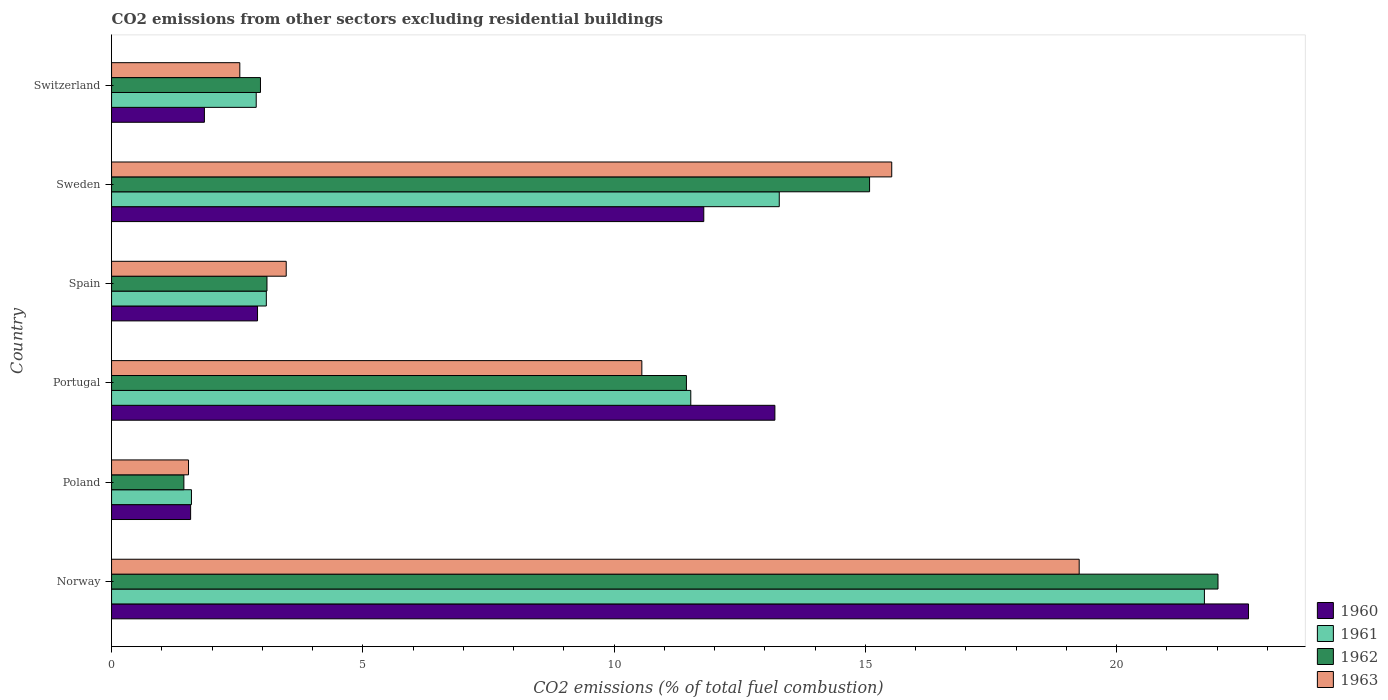How many different coloured bars are there?
Make the answer very short. 4. How many groups of bars are there?
Your response must be concise. 6. Are the number of bars per tick equal to the number of legend labels?
Provide a succinct answer. Yes. Are the number of bars on each tick of the Y-axis equal?
Make the answer very short. Yes. How many bars are there on the 4th tick from the top?
Your answer should be very brief. 4. How many bars are there on the 4th tick from the bottom?
Your answer should be compact. 4. What is the label of the 1st group of bars from the top?
Your answer should be very brief. Switzerland. What is the total CO2 emitted in 1963 in Switzerland?
Your answer should be very brief. 2.55. Across all countries, what is the maximum total CO2 emitted in 1962?
Offer a very short reply. 22.02. Across all countries, what is the minimum total CO2 emitted in 1960?
Your answer should be very brief. 1.57. In which country was the total CO2 emitted in 1960 minimum?
Ensure brevity in your answer.  Poland. What is the total total CO2 emitted in 1961 in the graph?
Your answer should be compact. 54.11. What is the difference between the total CO2 emitted in 1961 in Norway and that in Sweden?
Give a very brief answer. 8.46. What is the difference between the total CO2 emitted in 1962 in Sweden and the total CO2 emitted in 1960 in Spain?
Ensure brevity in your answer.  12.18. What is the average total CO2 emitted in 1961 per country?
Ensure brevity in your answer.  9.02. What is the difference between the total CO2 emitted in 1960 and total CO2 emitted in 1963 in Switzerland?
Make the answer very short. -0.7. What is the ratio of the total CO2 emitted in 1961 in Poland to that in Spain?
Ensure brevity in your answer.  0.52. Is the total CO2 emitted in 1962 in Norway less than that in Portugal?
Ensure brevity in your answer.  No. Is the difference between the total CO2 emitted in 1960 in Poland and Portugal greater than the difference between the total CO2 emitted in 1963 in Poland and Portugal?
Ensure brevity in your answer.  No. What is the difference between the highest and the second highest total CO2 emitted in 1960?
Provide a succinct answer. 9.43. What is the difference between the highest and the lowest total CO2 emitted in 1961?
Keep it short and to the point. 20.16. In how many countries, is the total CO2 emitted in 1962 greater than the average total CO2 emitted in 1962 taken over all countries?
Give a very brief answer. 3. What does the 2nd bar from the top in Switzerland represents?
Keep it short and to the point. 1962. What does the 3rd bar from the bottom in Portugal represents?
Your answer should be compact. 1962. Are all the bars in the graph horizontal?
Your response must be concise. Yes. Are the values on the major ticks of X-axis written in scientific E-notation?
Keep it short and to the point. No. Does the graph contain any zero values?
Provide a short and direct response. No. Does the graph contain grids?
Offer a very short reply. No. What is the title of the graph?
Provide a short and direct response. CO2 emissions from other sectors excluding residential buildings. Does "1995" appear as one of the legend labels in the graph?
Your response must be concise. No. What is the label or title of the X-axis?
Make the answer very short. CO2 emissions (% of total fuel combustion). What is the CO2 emissions (% of total fuel combustion) of 1960 in Norway?
Your answer should be compact. 22.63. What is the CO2 emissions (% of total fuel combustion) of 1961 in Norway?
Your answer should be very brief. 21.75. What is the CO2 emissions (% of total fuel combustion) of 1962 in Norway?
Offer a very short reply. 22.02. What is the CO2 emissions (% of total fuel combustion) of 1963 in Norway?
Your answer should be compact. 19.26. What is the CO2 emissions (% of total fuel combustion) of 1960 in Poland?
Give a very brief answer. 1.57. What is the CO2 emissions (% of total fuel combustion) in 1961 in Poland?
Provide a succinct answer. 1.59. What is the CO2 emissions (% of total fuel combustion) of 1962 in Poland?
Keep it short and to the point. 1.44. What is the CO2 emissions (% of total fuel combustion) in 1963 in Poland?
Offer a terse response. 1.53. What is the CO2 emissions (% of total fuel combustion) of 1960 in Portugal?
Ensure brevity in your answer.  13.2. What is the CO2 emissions (% of total fuel combustion) in 1961 in Portugal?
Give a very brief answer. 11.53. What is the CO2 emissions (% of total fuel combustion) in 1962 in Portugal?
Give a very brief answer. 11.44. What is the CO2 emissions (% of total fuel combustion) in 1963 in Portugal?
Give a very brief answer. 10.55. What is the CO2 emissions (% of total fuel combustion) in 1960 in Spain?
Your response must be concise. 2.91. What is the CO2 emissions (% of total fuel combustion) of 1961 in Spain?
Ensure brevity in your answer.  3.08. What is the CO2 emissions (% of total fuel combustion) of 1962 in Spain?
Your answer should be very brief. 3.09. What is the CO2 emissions (% of total fuel combustion) of 1963 in Spain?
Give a very brief answer. 3.48. What is the CO2 emissions (% of total fuel combustion) of 1960 in Sweden?
Provide a succinct answer. 11.79. What is the CO2 emissions (% of total fuel combustion) of 1961 in Sweden?
Keep it short and to the point. 13.29. What is the CO2 emissions (% of total fuel combustion) in 1962 in Sweden?
Offer a terse response. 15.09. What is the CO2 emissions (% of total fuel combustion) in 1963 in Sweden?
Offer a terse response. 15.53. What is the CO2 emissions (% of total fuel combustion) of 1960 in Switzerland?
Offer a very short reply. 1.85. What is the CO2 emissions (% of total fuel combustion) of 1961 in Switzerland?
Your answer should be very brief. 2.88. What is the CO2 emissions (% of total fuel combustion) in 1962 in Switzerland?
Ensure brevity in your answer.  2.96. What is the CO2 emissions (% of total fuel combustion) of 1963 in Switzerland?
Your answer should be very brief. 2.55. Across all countries, what is the maximum CO2 emissions (% of total fuel combustion) of 1960?
Provide a short and direct response. 22.63. Across all countries, what is the maximum CO2 emissions (% of total fuel combustion) in 1961?
Provide a short and direct response. 21.75. Across all countries, what is the maximum CO2 emissions (% of total fuel combustion) of 1962?
Offer a very short reply. 22.02. Across all countries, what is the maximum CO2 emissions (% of total fuel combustion) in 1963?
Ensure brevity in your answer.  19.26. Across all countries, what is the minimum CO2 emissions (% of total fuel combustion) in 1960?
Offer a terse response. 1.57. Across all countries, what is the minimum CO2 emissions (% of total fuel combustion) in 1961?
Offer a very short reply. 1.59. Across all countries, what is the minimum CO2 emissions (% of total fuel combustion) of 1962?
Make the answer very short. 1.44. Across all countries, what is the minimum CO2 emissions (% of total fuel combustion) in 1963?
Ensure brevity in your answer.  1.53. What is the total CO2 emissions (% of total fuel combustion) in 1960 in the graph?
Make the answer very short. 53.94. What is the total CO2 emissions (% of total fuel combustion) in 1961 in the graph?
Your response must be concise. 54.11. What is the total CO2 emissions (% of total fuel combustion) in 1962 in the graph?
Offer a very short reply. 56.04. What is the total CO2 emissions (% of total fuel combustion) of 1963 in the graph?
Give a very brief answer. 52.9. What is the difference between the CO2 emissions (% of total fuel combustion) of 1960 in Norway and that in Poland?
Your answer should be very brief. 21.05. What is the difference between the CO2 emissions (% of total fuel combustion) in 1961 in Norway and that in Poland?
Ensure brevity in your answer.  20.16. What is the difference between the CO2 emissions (% of total fuel combustion) of 1962 in Norway and that in Poland?
Ensure brevity in your answer.  20.58. What is the difference between the CO2 emissions (% of total fuel combustion) in 1963 in Norway and that in Poland?
Offer a terse response. 17.73. What is the difference between the CO2 emissions (% of total fuel combustion) in 1960 in Norway and that in Portugal?
Your answer should be compact. 9.43. What is the difference between the CO2 emissions (% of total fuel combustion) in 1961 in Norway and that in Portugal?
Your answer should be compact. 10.22. What is the difference between the CO2 emissions (% of total fuel combustion) of 1962 in Norway and that in Portugal?
Provide a succinct answer. 10.58. What is the difference between the CO2 emissions (% of total fuel combustion) in 1963 in Norway and that in Portugal?
Make the answer very short. 8.7. What is the difference between the CO2 emissions (% of total fuel combustion) of 1960 in Norway and that in Spain?
Ensure brevity in your answer.  19.72. What is the difference between the CO2 emissions (% of total fuel combustion) in 1961 in Norway and that in Spain?
Your answer should be compact. 18.67. What is the difference between the CO2 emissions (% of total fuel combustion) in 1962 in Norway and that in Spain?
Your answer should be very brief. 18.93. What is the difference between the CO2 emissions (% of total fuel combustion) in 1963 in Norway and that in Spain?
Provide a succinct answer. 15.78. What is the difference between the CO2 emissions (% of total fuel combustion) of 1960 in Norway and that in Sweden?
Your answer should be very brief. 10.84. What is the difference between the CO2 emissions (% of total fuel combustion) of 1961 in Norway and that in Sweden?
Give a very brief answer. 8.46. What is the difference between the CO2 emissions (% of total fuel combustion) of 1962 in Norway and that in Sweden?
Provide a succinct answer. 6.93. What is the difference between the CO2 emissions (% of total fuel combustion) in 1963 in Norway and that in Sweden?
Ensure brevity in your answer.  3.73. What is the difference between the CO2 emissions (% of total fuel combustion) in 1960 in Norway and that in Switzerland?
Provide a succinct answer. 20.78. What is the difference between the CO2 emissions (% of total fuel combustion) in 1961 in Norway and that in Switzerland?
Give a very brief answer. 18.87. What is the difference between the CO2 emissions (% of total fuel combustion) in 1962 in Norway and that in Switzerland?
Make the answer very short. 19.06. What is the difference between the CO2 emissions (% of total fuel combustion) of 1963 in Norway and that in Switzerland?
Ensure brevity in your answer.  16.7. What is the difference between the CO2 emissions (% of total fuel combustion) in 1960 in Poland and that in Portugal?
Offer a terse response. -11.63. What is the difference between the CO2 emissions (% of total fuel combustion) in 1961 in Poland and that in Portugal?
Ensure brevity in your answer.  -9.94. What is the difference between the CO2 emissions (% of total fuel combustion) in 1962 in Poland and that in Portugal?
Your answer should be very brief. -10. What is the difference between the CO2 emissions (% of total fuel combustion) of 1963 in Poland and that in Portugal?
Ensure brevity in your answer.  -9.02. What is the difference between the CO2 emissions (% of total fuel combustion) of 1960 in Poland and that in Spain?
Give a very brief answer. -1.33. What is the difference between the CO2 emissions (% of total fuel combustion) of 1961 in Poland and that in Spain?
Provide a succinct answer. -1.49. What is the difference between the CO2 emissions (% of total fuel combustion) of 1962 in Poland and that in Spain?
Make the answer very short. -1.65. What is the difference between the CO2 emissions (% of total fuel combustion) of 1963 in Poland and that in Spain?
Your answer should be very brief. -1.94. What is the difference between the CO2 emissions (% of total fuel combustion) in 1960 in Poland and that in Sweden?
Make the answer very short. -10.21. What is the difference between the CO2 emissions (% of total fuel combustion) in 1961 in Poland and that in Sweden?
Provide a short and direct response. -11.7. What is the difference between the CO2 emissions (% of total fuel combustion) in 1962 in Poland and that in Sweden?
Provide a succinct answer. -13.65. What is the difference between the CO2 emissions (% of total fuel combustion) in 1963 in Poland and that in Sweden?
Ensure brevity in your answer.  -13.99. What is the difference between the CO2 emissions (% of total fuel combustion) in 1960 in Poland and that in Switzerland?
Give a very brief answer. -0.27. What is the difference between the CO2 emissions (% of total fuel combustion) of 1961 in Poland and that in Switzerland?
Provide a succinct answer. -1.29. What is the difference between the CO2 emissions (% of total fuel combustion) of 1962 in Poland and that in Switzerland?
Give a very brief answer. -1.52. What is the difference between the CO2 emissions (% of total fuel combustion) of 1963 in Poland and that in Switzerland?
Your response must be concise. -1.02. What is the difference between the CO2 emissions (% of total fuel combustion) in 1960 in Portugal and that in Spain?
Provide a short and direct response. 10.3. What is the difference between the CO2 emissions (% of total fuel combustion) in 1961 in Portugal and that in Spain?
Provide a short and direct response. 8.45. What is the difference between the CO2 emissions (% of total fuel combustion) in 1962 in Portugal and that in Spain?
Your answer should be very brief. 8.35. What is the difference between the CO2 emissions (% of total fuel combustion) of 1963 in Portugal and that in Spain?
Make the answer very short. 7.08. What is the difference between the CO2 emissions (% of total fuel combustion) of 1960 in Portugal and that in Sweden?
Offer a terse response. 1.42. What is the difference between the CO2 emissions (% of total fuel combustion) in 1961 in Portugal and that in Sweden?
Give a very brief answer. -1.76. What is the difference between the CO2 emissions (% of total fuel combustion) of 1962 in Portugal and that in Sweden?
Provide a succinct answer. -3.65. What is the difference between the CO2 emissions (% of total fuel combustion) in 1963 in Portugal and that in Sweden?
Your response must be concise. -4.97. What is the difference between the CO2 emissions (% of total fuel combustion) in 1960 in Portugal and that in Switzerland?
Provide a succinct answer. 11.35. What is the difference between the CO2 emissions (% of total fuel combustion) of 1961 in Portugal and that in Switzerland?
Your answer should be compact. 8.65. What is the difference between the CO2 emissions (% of total fuel combustion) of 1962 in Portugal and that in Switzerland?
Ensure brevity in your answer.  8.48. What is the difference between the CO2 emissions (% of total fuel combustion) of 1963 in Portugal and that in Switzerland?
Your answer should be very brief. 8. What is the difference between the CO2 emissions (% of total fuel combustion) in 1960 in Spain and that in Sweden?
Your response must be concise. -8.88. What is the difference between the CO2 emissions (% of total fuel combustion) of 1961 in Spain and that in Sweden?
Provide a short and direct response. -10.21. What is the difference between the CO2 emissions (% of total fuel combustion) of 1962 in Spain and that in Sweden?
Your answer should be very brief. -11.99. What is the difference between the CO2 emissions (% of total fuel combustion) of 1963 in Spain and that in Sweden?
Offer a terse response. -12.05. What is the difference between the CO2 emissions (% of total fuel combustion) of 1960 in Spain and that in Switzerland?
Offer a terse response. 1.06. What is the difference between the CO2 emissions (% of total fuel combustion) in 1961 in Spain and that in Switzerland?
Keep it short and to the point. 0.2. What is the difference between the CO2 emissions (% of total fuel combustion) in 1962 in Spain and that in Switzerland?
Offer a very short reply. 0.13. What is the difference between the CO2 emissions (% of total fuel combustion) of 1963 in Spain and that in Switzerland?
Make the answer very short. 0.92. What is the difference between the CO2 emissions (% of total fuel combustion) of 1960 in Sweden and that in Switzerland?
Make the answer very short. 9.94. What is the difference between the CO2 emissions (% of total fuel combustion) in 1961 in Sweden and that in Switzerland?
Your answer should be compact. 10.41. What is the difference between the CO2 emissions (% of total fuel combustion) of 1962 in Sweden and that in Switzerland?
Give a very brief answer. 12.12. What is the difference between the CO2 emissions (% of total fuel combustion) in 1963 in Sweden and that in Switzerland?
Provide a short and direct response. 12.97. What is the difference between the CO2 emissions (% of total fuel combustion) in 1960 in Norway and the CO2 emissions (% of total fuel combustion) in 1961 in Poland?
Give a very brief answer. 21.04. What is the difference between the CO2 emissions (% of total fuel combustion) in 1960 in Norway and the CO2 emissions (% of total fuel combustion) in 1962 in Poland?
Provide a succinct answer. 21.19. What is the difference between the CO2 emissions (% of total fuel combustion) in 1960 in Norway and the CO2 emissions (% of total fuel combustion) in 1963 in Poland?
Your answer should be very brief. 21.1. What is the difference between the CO2 emissions (% of total fuel combustion) of 1961 in Norway and the CO2 emissions (% of total fuel combustion) of 1962 in Poland?
Offer a terse response. 20.31. What is the difference between the CO2 emissions (% of total fuel combustion) in 1961 in Norway and the CO2 emissions (% of total fuel combustion) in 1963 in Poland?
Your answer should be compact. 20.22. What is the difference between the CO2 emissions (% of total fuel combustion) in 1962 in Norway and the CO2 emissions (% of total fuel combustion) in 1963 in Poland?
Your response must be concise. 20.49. What is the difference between the CO2 emissions (% of total fuel combustion) in 1960 in Norway and the CO2 emissions (% of total fuel combustion) in 1961 in Portugal?
Keep it short and to the point. 11.1. What is the difference between the CO2 emissions (% of total fuel combustion) in 1960 in Norway and the CO2 emissions (% of total fuel combustion) in 1962 in Portugal?
Your response must be concise. 11.19. What is the difference between the CO2 emissions (% of total fuel combustion) in 1960 in Norway and the CO2 emissions (% of total fuel combustion) in 1963 in Portugal?
Ensure brevity in your answer.  12.07. What is the difference between the CO2 emissions (% of total fuel combustion) of 1961 in Norway and the CO2 emissions (% of total fuel combustion) of 1962 in Portugal?
Give a very brief answer. 10.31. What is the difference between the CO2 emissions (% of total fuel combustion) in 1961 in Norway and the CO2 emissions (% of total fuel combustion) in 1963 in Portugal?
Your response must be concise. 11.2. What is the difference between the CO2 emissions (% of total fuel combustion) of 1962 in Norway and the CO2 emissions (% of total fuel combustion) of 1963 in Portugal?
Give a very brief answer. 11.47. What is the difference between the CO2 emissions (% of total fuel combustion) of 1960 in Norway and the CO2 emissions (% of total fuel combustion) of 1961 in Spain?
Offer a very short reply. 19.55. What is the difference between the CO2 emissions (% of total fuel combustion) of 1960 in Norway and the CO2 emissions (% of total fuel combustion) of 1962 in Spain?
Provide a succinct answer. 19.53. What is the difference between the CO2 emissions (% of total fuel combustion) of 1960 in Norway and the CO2 emissions (% of total fuel combustion) of 1963 in Spain?
Make the answer very short. 19.15. What is the difference between the CO2 emissions (% of total fuel combustion) of 1961 in Norway and the CO2 emissions (% of total fuel combustion) of 1962 in Spain?
Keep it short and to the point. 18.66. What is the difference between the CO2 emissions (% of total fuel combustion) of 1961 in Norway and the CO2 emissions (% of total fuel combustion) of 1963 in Spain?
Give a very brief answer. 18.27. What is the difference between the CO2 emissions (% of total fuel combustion) in 1962 in Norway and the CO2 emissions (% of total fuel combustion) in 1963 in Spain?
Give a very brief answer. 18.54. What is the difference between the CO2 emissions (% of total fuel combustion) in 1960 in Norway and the CO2 emissions (% of total fuel combustion) in 1961 in Sweden?
Offer a very short reply. 9.34. What is the difference between the CO2 emissions (% of total fuel combustion) of 1960 in Norway and the CO2 emissions (% of total fuel combustion) of 1962 in Sweden?
Provide a short and direct response. 7.54. What is the difference between the CO2 emissions (% of total fuel combustion) of 1960 in Norway and the CO2 emissions (% of total fuel combustion) of 1963 in Sweden?
Offer a terse response. 7.1. What is the difference between the CO2 emissions (% of total fuel combustion) in 1961 in Norway and the CO2 emissions (% of total fuel combustion) in 1962 in Sweden?
Ensure brevity in your answer.  6.66. What is the difference between the CO2 emissions (% of total fuel combustion) of 1961 in Norway and the CO2 emissions (% of total fuel combustion) of 1963 in Sweden?
Provide a succinct answer. 6.22. What is the difference between the CO2 emissions (% of total fuel combustion) of 1962 in Norway and the CO2 emissions (% of total fuel combustion) of 1963 in Sweden?
Provide a succinct answer. 6.49. What is the difference between the CO2 emissions (% of total fuel combustion) of 1960 in Norway and the CO2 emissions (% of total fuel combustion) of 1961 in Switzerland?
Provide a short and direct response. 19.75. What is the difference between the CO2 emissions (% of total fuel combustion) in 1960 in Norway and the CO2 emissions (% of total fuel combustion) in 1962 in Switzerland?
Keep it short and to the point. 19.66. What is the difference between the CO2 emissions (% of total fuel combustion) of 1960 in Norway and the CO2 emissions (% of total fuel combustion) of 1963 in Switzerland?
Make the answer very short. 20.07. What is the difference between the CO2 emissions (% of total fuel combustion) of 1961 in Norway and the CO2 emissions (% of total fuel combustion) of 1962 in Switzerland?
Give a very brief answer. 18.79. What is the difference between the CO2 emissions (% of total fuel combustion) of 1961 in Norway and the CO2 emissions (% of total fuel combustion) of 1963 in Switzerland?
Offer a terse response. 19.2. What is the difference between the CO2 emissions (% of total fuel combustion) of 1962 in Norway and the CO2 emissions (% of total fuel combustion) of 1963 in Switzerland?
Provide a short and direct response. 19.47. What is the difference between the CO2 emissions (% of total fuel combustion) in 1960 in Poland and the CO2 emissions (% of total fuel combustion) in 1961 in Portugal?
Ensure brevity in your answer.  -9.95. What is the difference between the CO2 emissions (% of total fuel combustion) of 1960 in Poland and the CO2 emissions (% of total fuel combustion) of 1962 in Portugal?
Keep it short and to the point. -9.87. What is the difference between the CO2 emissions (% of total fuel combustion) of 1960 in Poland and the CO2 emissions (% of total fuel combustion) of 1963 in Portugal?
Your answer should be very brief. -8.98. What is the difference between the CO2 emissions (% of total fuel combustion) in 1961 in Poland and the CO2 emissions (% of total fuel combustion) in 1962 in Portugal?
Your response must be concise. -9.85. What is the difference between the CO2 emissions (% of total fuel combustion) in 1961 in Poland and the CO2 emissions (% of total fuel combustion) in 1963 in Portugal?
Keep it short and to the point. -8.96. What is the difference between the CO2 emissions (% of total fuel combustion) of 1962 in Poland and the CO2 emissions (% of total fuel combustion) of 1963 in Portugal?
Provide a short and direct response. -9.11. What is the difference between the CO2 emissions (% of total fuel combustion) in 1960 in Poland and the CO2 emissions (% of total fuel combustion) in 1961 in Spain?
Offer a terse response. -1.51. What is the difference between the CO2 emissions (% of total fuel combustion) in 1960 in Poland and the CO2 emissions (% of total fuel combustion) in 1962 in Spain?
Your answer should be very brief. -1.52. What is the difference between the CO2 emissions (% of total fuel combustion) in 1960 in Poland and the CO2 emissions (% of total fuel combustion) in 1963 in Spain?
Make the answer very short. -1.9. What is the difference between the CO2 emissions (% of total fuel combustion) in 1961 in Poland and the CO2 emissions (% of total fuel combustion) in 1962 in Spain?
Ensure brevity in your answer.  -1.5. What is the difference between the CO2 emissions (% of total fuel combustion) in 1961 in Poland and the CO2 emissions (% of total fuel combustion) in 1963 in Spain?
Ensure brevity in your answer.  -1.89. What is the difference between the CO2 emissions (% of total fuel combustion) in 1962 in Poland and the CO2 emissions (% of total fuel combustion) in 1963 in Spain?
Your response must be concise. -2.04. What is the difference between the CO2 emissions (% of total fuel combustion) in 1960 in Poland and the CO2 emissions (% of total fuel combustion) in 1961 in Sweden?
Give a very brief answer. -11.71. What is the difference between the CO2 emissions (% of total fuel combustion) in 1960 in Poland and the CO2 emissions (% of total fuel combustion) in 1962 in Sweden?
Ensure brevity in your answer.  -13.51. What is the difference between the CO2 emissions (% of total fuel combustion) of 1960 in Poland and the CO2 emissions (% of total fuel combustion) of 1963 in Sweden?
Offer a very short reply. -13.95. What is the difference between the CO2 emissions (% of total fuel combustion) of 1961 in Poland and the CO2 emissions (% of total fuel combustion) of 1962 in Sweden?
Ensure brevity in your answer.  -13.5. What is the difference between the CO2 emissions (% of total fuel combustion) of 1961 in Poland and the CO2 emissions (% of total fuel combustion) of 1963 in Sweden?
Keep it short and to the point. -13.94. What is the difference between the CO2 emissions (% of total fuel combustion) in 1962 in Poland and the CO2 emissions (% of total fuel combustion) in 1963 in Sweden?
Make the answer very short. -14.09. What is the difference between the CO2 emissions (% of total fuel combustion) of 1960 in Poland and the CO2 emissions (% of total fuel combustion) of 1961 in Switzerland?
Your response must be concise. -1.31. What is the difference between the CO2 emissions (% of total fuel combustion) of 1960 in Poland and the CO2 emissions (% of total fuel combustion) of 1962 in Switzerland?
Provide a short and direct response. -1.39. What is the difference between the CO2 emissions (% of total fuel combustion) in 1960 in Poland and the CO2 emissions (% of total fuel combustion) in 1963 in Switzerland?
Your response must be concise. -0.98. What is the difference between the CO2 emissions (% of total fuel combustion) in 1961 in Poland and the CO2 emissions (% of total fuel combustion) in 1962 in Switzerland?
Provide a short and direct response. -1.37. What is the difference between the CO2 emissions (% of total fuel combustion) in 1961 in Poland and the CO2 emissions (% of total fuel combustion) in 1963 in Switzerland?
Provide a succinct answer. -0.96. What is the difference between the CO2 emissions (% of total fuel combustion) of 1962 in Poland and the CO2 emissions (% of total fuel combustion) of 1963 in Switzerland?
Provide a succinct answer. -1.11. What is the difference between the CO2 emissions (% of total fuel combustion) of 1960 in Portugal and the CO2 emissions (% of total fuel combustion) of 1961 in Spain?
Keep it short and to the point. 10.12. What is the difference between the CO2 emissions (% of total fuel combustion) in 1960 in Portugal and the CO2 emissions (% of total fuel combustion) in 1962 in Spain?
Your answer should be compact. 10.11. What is the difference between the CO2 emissions (% of total fuel combustion) in 1960 in Portugal and the CO2 emissions (% of total fuel combustion) in 1963 in Spain?
Provide a succinct answer. 9.73. What is the difference between the CO2 emissions (% of total fuel combustion) of 1961 in Portugal and the CO2 emissions (% of total fuel combustion) of 1962 in Spain?
Your answer should be very brief. 8.43. What is the difference between the CO2 emissions (% of total fuel combustion) of 1961 in Portugal and the CO2 emissions (% of total fuel combustion) of 1963 in Spain?
Give a very brief answer. 8.05. What is the difference between the CO2 emissions (% of total fuel combustion) in 1962 in Portugal and the CO2 emissions (% of total fuel combustion) in 1963 in Spain?
Your answer should be compact. 7.96. What is the difference between the CO2 emissions (% of total fuel combustion) in 1960 in Portugal and the CO2 emissions (% of total fuel combustion) in 1961 in Sweden?
Provide a succinct answer. -0.09. What is the difference between the CO2 emissions (% of total fuel combustion) of 1960 in Portugal and the CO2 emissions (% of total fuel combustion) of 1962 in Sweden?
Offer a terse response. -1.88. What is the difference between the CO2 emissions (% of total fuel combustion) in 1960 in Portugal and the CO2 emissions (% of total fuel combustion) in 1963 in Sweden?
Make the answer very short. -2.33. What is the difference between the CO2 emissions (% of total fuel combustion) of 1961 in Portugal and the CO2 emissions (% of total fuel combustion) of 1962 in Sweden?
Offer a very short reply. -3.56. What is the difference between the CO2 emissions (% of total fuel combustion) of 1961 in Portugal and the CO2 emissions (% of total fuel combustion) of 1963 in Sweden?
Offer a very short reply. -4. What is the difference between the CO2 emissions (% of total fuel combustion) of 1962 in Portugal and the CO2 emissions (% of total fuel combustion) of 1963 in Sweden?
Give a very brief answer. -4.09. What is the difference between the CO2 emissions (% of total fuel combustion) of 1960 in Portugal and the CO2 emissions (% of total fuel combustion) of 1961 in Switzerland?
Offer a very short reply. 10.32. What is the difference between the CO2 emissions (% of total fuel combustion) in 1960 in Portugal and the CO2 emissions (% of total fuel combustion) in 1962 in Switzerland?
Provide a short and direct response. 10.24. What is the difference between the CO2 emissions (% of total fuel combustion) in 1960 in Portugal and the CO2 emissions (% of total fuel combustion) in 1963 in Switzerland?
Keep it short and to the point. 10.65. What is the difference between the CO2 emissions (% of total fuel combustion) in 1961 in Portugal and the CO2 emissions (% of total fuel combustion) in 1962 in Switzerland?
Your answer should be compact. 8.56. What is the difference between the CO2 emissions (% of total fuel combustion) of 1961 in Portugal and the CO2 emissions (% of total fuel combustion) of 1963 in Switzerland?
Ensure brevity in your answer.  8.97. What is the difference between the CO2 emissions (% of total fuel combustion) of 1962 in Portugal and the CO2 emissions (% of total fuel combustion) of 1963 in Switzerland?
Give a very brief answer. 8.89. What is the difference between the CO2 emissions (% of total fuel combustion) of 1960 in Spain and the CO2 emissions (% of total fuel combustion) of 1961 in Sweden?
Make the answer very short. -10.38. What is the difference between the CO2 emissions (% of total fuel combustion) in 1960 in Spain and the CO2 emissions (% of total fuel combustion) in 1962 in Sweden?
Make the answer very short. -12.18. What is the difference between the CO2 emissions (% of total fuel combustion) of 1960 in Spain and the CO2 emissions (% of total fuel combustion) of 1963 in Sweden?
Offer a terse response. -12.62. What is the difference between the CO2 emissions (% of total fuel combustion) in 1961 in Spain and the CO2 emissions (% of total fuel combustion) in 1962 in Sweden?
Make the answer very short. -12.01. What is the difference between the CO2 emissions (% of total fuel combustion) in 1961 in Spain and the CO2 emissions (% of total fuel combustion) in 1963 in Sweden?
Your response must be concise. -12.45. What is the difference between the CO2 emissions (% of total fuel combustion) in 1962 in Spain and the CO2 emissions (% of total fuel combustion) in 1963 in Sweden?
Keep it short and to the point. -12.43. What is the difference between the CO2 emissions (% of total fuel combustion) of 1960 in Spain and the CO2 emissions (% of total fuel combustion) of 1961 in Switzerland?
Keep it short and to the point. 0.03. What is the difference between the CO2 emissions (% of total fuel combustion) in 1960 in Spain and the CO2 emissions (% of total fuel combustion) in 1962 in Switzerland?
Your answer should be very brief. -0.06. What is the difference between the CO2 emissions (% of total fuel combustion) of 1960 in Spain and the CO2 emissions (% of total fuel combustion) of 1963 in Switzerland?
Provide a short and direct response. 0.35. What is the difference between the CO2 emissions (% of total fuel combustion) in 1961 in Spain and the CO2 emissions (% of total fuel combustion) in 1962 in Switzerland?
Offer a very short reply. 0.12. What is the difference between the CO2 emissions (% of total fuel combustion) in 1961 in Spain and the CO2 emissions (% of total fuel combustion) in 1963 in Switzerland?
Ensure brevity in your answer.  0.53. What is the difference between the CO2 emissions (% of total fuel combustion) of 1962 in Spain and the CO2 emissions (% of total fuel combustion) of 1963 in Switzerland?
Ensure brevity in your answer.  0.54. What is the difference between the CO2 emissions (% of total fuel combustion) in 1960 in Sweden and the CO2 emissions (% of total fuel combustion) in 1961 in Switzerland?
Keep it short and to the point. 8.91. What is the difference between the CO2 emissions (% of total fuel combustion) in 1960 in Sweden and the CO2 emissions (% of total fuel combustion) in 1962 in Switzerland?
Your response must be concise. 8.82. What is the difference between the CO2 emissions (% of total fuel combustion) in 1960 in Sweden and the CO2 emissions (% of total fuel combustion) in 1963 in Switzerland?
Ensure brevity in your answer.  9.23. What is the difference between the CO2 emissions (% of total fuel combustion) in 1961 in Sweden and the CO2 emissions (% of total fuel combustion) in 1962 in Switzerland?
Make the answer very short. 10.32. What is the difference between the CO2 emissions (% of total fuel combustion) in 1961 in Sweden and the CO2 emissions (% of total fuel combustion) in 1963 in Switzerland?
Your answer should be very brief. 10.74. What is the difference between the CO2 emissions (% of total fuel combustion) of 1962 in Sweden and the CO2 emissions (% of total fuel combustion) of 1963 in Switzerland?
Offer a very short reply. 12.53. What is the average CO2 emissions (% of total fuel combustion) in 1960 per country?
Offer a terse response. 8.99. What is the average CO2 emissions (% of total fuel combustion) of 1961 per country?
Your answer should be very brief. 9.02. What is the average CO2 emissions (% of total fuel combustion) of 1962 per country?
Provide a succinct answer. 9.34. What is the average CO2 emissions (% of total fuel combustion) in 1963 per country?
Offer a terse response. 8.82. What is the difference between the CO2 emissions (% of total fuel combustion) of 1960 and CO2 emissions (% of total fuel combustion) of 1961 in Norway?
Your response must be concise. 0.88. What is the difference between the CO2 emissions (% of total fuel combustion) in 1960 and CO2 emissions (% of total fuel combustion) in 1962 in Norway?
Offer a terse response. 0.61. What is the difference between the CO2 emissions (% of total fuel combustion) in 1960 and CO2 emissions (% of total fuel combustion) in 1963 in Norway?
Offer a terse response. 3.37. What is the difference between the CO2 emissions (% of total fuel combustion) in 1961 and CO2 emissions (% of total fuel combustion) in 1962 in Norway?
Ensure brevity in your answer.  -0.27. What is the difference between the CO2 emissions (% of total fuel combustion) in 1961 and CO2 emissions (% of total fuel combustion) in 1963 in Norway?
Offer a very short reply. 2.49. What is the difference between the CO2 emissions (% of total fuel combustion) of 1962 and CO2 emissions (% of total fuel combustion) of 1963 in Norway?
Offer a very short reply. 2.76. What is the difference between the CO2 emissions (% of total fuel combustion) of 1960 and CO2 emissions (% of total fuel combustion) of 1961 in Poland?
Offer a very short reply. -0.02. What is the difference between the CO2 emissions (% of total fuel combustion) of 1960 and CO2 emissions (% of total fuel combustion) of 1962 in Poland?
Make the answer very short. 0.13. What is the difference between the CO2 emissions (% of total fuel combustion) of 1960 and CO2 emissions (% of total fuel combustion) of 1963 in Poland?
Your answer should be compact. 0.04. What is the difference between the CO2 emissions (% of total fuel combustion) of 1961 and CO2 emissions (% of total fuel combustion) of 1962 in Poland?
Offer a very short reply. 0.15. What is the difference between the CO2 emissions (% of total fuel combustion) in 1961 and CO2 emissions (% of total fuel combustion) in 1963 in Poland?
Provide a short and direct response. 0.06. What is the difference between the CO2 emissions (% of total fuel combustion) of 1962 and CO2 emissions (% of total fuel combustion) of 1963 in Poland?
Ensure brevity in your answer.  -0.09. What is the difference between the CO2 emissions (% of total fuel combustion) of 1960 and CO2 emissions (% of total fuel combustion) of 1961 in Portugal?
Offer a terse response. 1.67. What is the difference between the CO2 emissions (% of total fuel combustion) in 1960 and CO2 emissions (% of total fuel combustion) in 1962 in Portugal?
Make the answer very short. 1.76. What is the difference between the CO2 emissions (% of total fuel combustion) in 1960 and CO2 emissions (% of total fuel combustion) in 1963 in Portugal?
Offer a very short reply. 2.65. What is the difference between the CO2 emissions (% of total fuel combustion) of 1961 and CO2 emissions (% of total fuel combustion) of 1962 in Portugal?
Give a very brief answer. 0.09. What is the difference between the CO2 emissions (% of total fuel combustion) of 1961 and CO2 emissions (% of total fuel combustion) of 1963 in Portugal?
Your answer should be very brief. 0.97. What is the difference between the CO2 emissions (% of total fuel combustion) of 1962 and CO2 emissions (% of total fuel combustion) of 1963 in Portugal?
Offer a terse response. 0.89. What is the difference between the CO2 emissions (% of total fuel combustion) of 1960 and CO2 emissions (% of total fuel combustion) of 1961 in Spain?
Offer a very short reply. -0.17. What is the difference between the CO2 emissions (% of total fuel combustion) of 1960 and CO2 emissions (% of total fuel combustion) of 1962 in Spain?
Provide a short and direct response. -0.19. What is the difference between the CO2 emissions (% of total fuel combustion) of 1960 and CO2 emissions (% of total fuel combustion) of 1963 in Spain?
Provide a succinct answer. -0.57. What is the difference between the CO2 emissions (% of total fuel combustion) of 1961 and CO2 emissions (% of total fuel combustion) of 1962 in Spain?
Make the answer very short. -0.01. What is the difference between the CO2 emissions (% of total fuel combustion) in 1961 and CO2 emissions (% of total fuel combustion) in 1963 in Spain?
Ensure brevity in your answer.  -0.4. What is the difference between the CO2 emissions (% of total fuel combustion) of 1962 and CO2 emissions (% of total fuel combustion) of 1963 in Spain?
Provide a short and direct response. -0.38. What is the difference between the CO2 emissions (% of total fuel combustion) in 1960 and CO2 emissions (% of total fuel combustion) in 1961 in Sweden?
Your answer should be very brief. -1.5. What is the difference between the CO2 emissions (% of total fuel combustion) in 1960 and CO2 emissions (% of total fuel combustion) in 1962 in Sweden?
Offer a very short reply. -3.3. What is the difference between the CO2 emissions (% of total fuel combustion) of 1960 and CO2 emissions (% of total fuel combustion) of 1963 in Sweden?
Ensure brevity in your answer.  -3.74. What is the difference between the CO2 emissions (% of total fuel combustion) of 1961 and CO2 emissions (% of total fuel combustion) of 1962 in Sweden?
Your answer should be very brief. -1.8. What is the difference between the CO2 emissions (% of total fuel combustion) of 1961 and CO2 emissions (% of total fuel combustion) of 1963 in Sweden?
Offer a terse response. -2.24. What is the difference between the CO2 emissions (% of total fuel combustion) of 1962 and CO2 emissions (% of total fuel combustion) of 1963 in Sweden?
Keep it short and to the point. -0.44. What is the difference between the CO2 emissions (% of total fuel combustion) of 1960 and CO2 emissions (% of total fuel combustion) of 1961 in Switzerland?
Offer a very short reply. -1.03. What is the difference between the CO2 emissions (% of total fuel combustion) of 1960 and CO2 emissions (% of total fuel combustion) of 1962 in Switzerland?
Your response must be concise. -1.12. What is the difference between the CO2 emissions (% of total fuel combustion) of 1960 and CO2 emissions (% of total fuel combustion) of 1963 in Switzerland?
Give a very brief answer. -0.7. What is the difference between the CO2 emissions (% of total fuel combustion) in 1961 and CO2 emissions (% of total fuel combustion) in 1962 in Switzerland?
Provide a short and direct response. -0.08. What is the difference between the CO2 emissions (% of total fuel combustion) in 1961 and CO2 emissions (% of total fuel combustion) in 1963 in Switzerland?
Make the answer very short. 0.33. What is the difference between the CO2 emissions (% of total fuel combustion) in 1962 and CO2 emissions (% of total fuel combustion) in 1963 in Switzerland?
Your answer should be compact. 0.41. What is the ratio of the CO2 emissions (% of total fuel combustion) in 1960 in Norway to that in Poland?
Make the answer very short. 14.38. What is the ratio of the CO2 emissions (% of total fuel combustion) in 1961 in Norway to that in Poland?
Offer a very short reply. 13.68. What is the ratio of the CO2 emissions (% of total fuel combustion) of 1962 in Norway to that in Poland?
Your answer should be very brief. 15.3. What is the ratio of the CO2 emissions (% of total fuel combustion) in 1963 in Norway to that in Poland?
Give a very brief answer. 12.57. What is the ratio of the CO2 emissions (% of total fuel combustion) in 1960 in Norway to that in Portugal?
Your answer should be compact. 1.71. What is the ratio of the CO2 emissions (% of total fuel combustion) in 1961 in Norway to that in Portugal?
Ensure brevity in your answer.  1.89. What is the ratio of the CO2 emissions (% of total fuel combustion) of 1962 in Norway to that in Portugal?
Keep it short and to the point. 1.92. What is the ratio of the CO2 emissions (% of total fuel combustion) of 1963 in Norway to that in Portugal?
Offer a terse response. 1.82. What is the ratio of the CO2 emissions (% of total fuel combustion) in 1960 in Norway to that in Spain?
Offer a very short reply. 7.79. What is the ratio of the CO2 emissions (% of total fuel combustion) of 1961 in Norway to that in Spain?
Your response must be concise. 7.06. What is the ratio of the CO2 emissions (% of total fuel combustion) in 1962 in Norway to that in Spain?
Provide a succinct answer. 7.12. What is the ratio of the CO2 emissions (% of total fuel combustion) of 1963 in Norway to that in Spain?
Your answer should be compact. 5.54. What is the ratio of the CO2 emissions (% of total fuel combustion) of 1960 in Norway to that in Sweden?
Your answer should be compact. 1.92. What is the ratio of the CO2 emissions (% of total fuel combustion) of 1961 in Norway to that in Sweden?
Offer a very short reply. 1.64. What is the ratio of the CO2 emissions (% of total fuel combustion) of 1962 in Norway to that in Sweden?
Make the answer very short. 1.46. What is the ratio of the CO2 emissions (% of total fuel combustion) of 1963 in Norway to that in Sweden?
Provide a succinct answer. 1.24. What is the ratio of the CO2 emissions (% of total fuel combustion) of 1960 in Norway to that in Switzerland?
Make the answer very short. 12.25. What is the ratio of the CO2 emissions (% of total fuel combustion) in 1961 in Norway to that in Switzerland?
Provide a short and direct response. 7.55. What is the ratio of the CO2 emissions (% of total fuel combustion) in 1962 in Norway to that in Switzerland?
Provide a short and direct response. 7.43. What is the ratio of the CO2 emissions (% of total fuel combustion) in 1963 in Norway to that in Switzerland?
Offer a very short reply. 7.54. What is the ratio of the CO2 emissions (% of total fuel combustion) of 1960 in Poland to that in Portugal?
Your response must be concise. 0.12. What is the ratio of the CO2 emissions (% of total fuel combustion) of 1961 in Poland to that in Portugal?
Offer a terse response. 0.14. What is the ratio of the CO2 emissions (% of total fuel combustion) of 1962 in Poland to that in Portugal?
Your answer should be very brief. 0.13. What is the ratio of the CO2 emissions (% of total fuel combustion) of 1963 in Poland to that in Portugal?
Ensure brevity in your answer.  0.15. What is the ratio of the CO2 emissions (% of total fuel combustion) in 1960 in Poland to that in Spain?
Keep it short and to the point. 0.54. What is the ratio of the CO2 emissions (% of total fuel combustion) in 1961 in Poland to that in Spain?
Offer a terse response. 0.52. What is the ratio of the CO2 emissions (% of total fuel combustion) of 1962 in Poland to that in Spain?
Ensure brevity in your answer.  0.47. What is the ratio of the CO2 emissions (% of total fuel combustion) in 1963 in Poland to that in Spain?
Give a very brief answer. 0.44. What is the ratio of the CO2 emissions (% of total fuel combustion) in 1960 in Poland to that in Sweden?
Provide a short and direct response. 0.13. What is the ratio of the CO2 emissions (% of total fuel combustion) of 1961 in Poland to that in Sweden?
Your answer should be compact. 0.12. What is the ratio of the CO2 emissions (% of total fuel combustion) of 1962 in Poland to that in Sweden?
Offer a very short reply. 0.1. What is the ratio of the CO2 emissions (% of total fuel combustion) in 1963 in Poland to that in Sweden?
Your response must be concise. 0.1. What is the ratio of the CO2 emissions (% of total fuel combustion) of 1960 in Poland to that in Switzerland?
Give a very brief answer. 0.85. What is the ratio of the CO2 emissions (% of total fuel combustion) in 1961 in Poland to that in Switzerland?
Your answer should be compact. 0.55. What is the ratio of the CO2 emissions (% of total fuel combustion) in 1962 in Poland to that in Switzerland?
Provide a succinct answer. 0.49. What is the ratio of the CO2 emissions (% of total fuel combustion) in 1963 in Poland to that in Switzerland?
Provide a succinct answer. 0.6. What is the ratio of the CO2 emissions (% of total fuel combustion) in 1960 in Portugal to that in Spain?
Offer a very short reply. 4.54. What is the ratio of the CO2 emissions (% of total fuel combustion) of 1961 in Portugal to that in Spain?
Offer a very short reply. 3.74. What is the ratio of the CO2 emissions (% of total fuel combustion) in 1962 in Portugal to that in Spain?
Offer a very short reply. 3.7. What is the ratio of the CO2 emissions (% of total fuel combustion) of 1963 in Portugal to that in Spain?
Your answer should be very brief. 3.04. What is the ratio of the CO2 emissions (% of total fuel combustion) of 1960 in Portugal to that in Sweden?
Provide a succinct answer. 1.12. What is the ratio of the CO2 emissions (% of total fuel combustion) of 1961 in Portugal to that in Sweden?
Your answer should be very brief. 0.87. What is the ratio of the CO2 emissions (% of total fuel combustion) in 1962 in Portugal to that in Sweden?
Your answer should be compact. 0.76. What is the ratio of the CO2 emissions (% of total fuel combustion) in 1963 in Portugal to that in Sweden?
Your answer should be very brief. 0.68. What is the ratio of the CO2 emissions (% of total fuel combustion) of 1960 in Portugal to that in Switzerland?
Your answer should be compact. 7.14. What is the ratio of the CO2 emissions (% of total fuel combustion) in 1961 in Portugal to that in Switzerland?
Give a very brief answer. 4. What is the ratio of the CO2 emissions (% of total fuel combustion) of 1962 in Portugal to that in Switzerland?
Offer a very short reply. 3.86. What is the ratio of the CO2 emissions (% of total fuel combustion) of 1963 in Portugal to that in Switzerland?
Your answer should be compact. 4.13. What is the ratio of the CO2 emissions (% of total fuel combustion) of 1960 in Spain to that in Sweden?
Ensure brevity in your answer.  0.25. What is the ratio of the CO2 emissions (% of total fuel combustion) in 1961 in Spain to that in Sweden?
Your answer should be compact. 0.23. What is the ratio of the CO2 emissions (% of total fuel combustion) of 1962 in Spain to that in Sweden?
Ensure brevity in your answer.  0.2. What is the ratio of the CO2 emissions (% of total fuel combustion) in 1963 in Spain to that in Sweden?
Keep it short and to the point. 0.22. What is the ratio of the CO2 emissions (% of total fuel combustion) of 1960 in Spain to that in Switzerland?
Provide a short and direct response. 1.57. What is the ratio of the CO2 emissions (% of total fuel combustion) in 1961 in Spain to that in Switzerland?
Offer a very short reply. 1.07. What is the ratio of the CO2 emissions (% of total fuel combustion) of 1962 in Spain to that in Switzerland?
Your answer should be compact. 1.04. What is the ratio of the CO2 emissions (% of total fuel combustion) of 1963 in Spain to that in Switzerland?
Offer a very short reply. 1.36. What is the ratio of the CO2 emissions (% of total fuel combustion) in 1960 in Sweden to that in Switzerland?
Your response must be concise. 6.38. What is the ratio of the CO2 emissions (% of total fuel combustion) of 1961 in Sweden to that in Switzerland?
Offer a very short reply. 4.62. What is the ratio of the CO2 emissions (% of total fuel combustion) in 1962 in Sweden to that in Switzerland?
Make the answer very short. 5.09. What is the ratio of the CO2 emissions (% of total fuel combustion) in 1963 in Sweden to that in Switzerland?
Keep it short and to the point. 6.08. What is the difference between the highest and the second highest CO2 emissions (% of total fuel combustion) in 1960?
Ensure brevity in your answer.  9.43. What is the difference between the highest and the second highest CO2 emissions (% of total fuel combustion) in 1961?
Give a very brief answer. 8.46. What is the difference between the highest and the second highest CO2 emissions (% of total fuel combustion) in 1962?
Offer a terse response. 6.93. What is the difference between the highest and the second highest CO2 emissions (% of total fuel combustion) of 1963?
Make the answer very short. 3.73. What is the difference between the highest and the lowest CO2 emissions (% of total fuel combustion) in 1960?
Give a very brief answer. 21.05. What is the difference between the highest and the lowest CO2 emissions (% of total fuel combustion) in 1961?
Your answer should be compact. 20.16. What is the difference between the highest and the lowest CO2 emissions (% of total fuel combustion) in 1962?
Your answer should be very brief. 20.58. What is the difference between the highest and the lowest CO2 emissions (% of total fuel combustion) of 1963?
Ensure brevity in your answer.  17.73. 